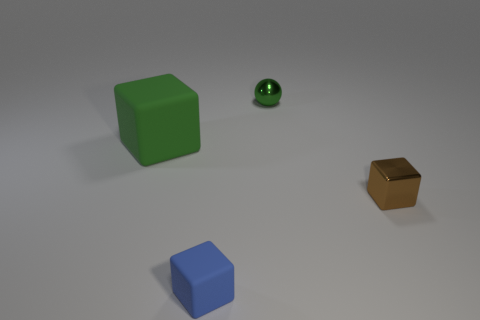Can you tell me what materials the objects might be made from? Based on their appearance in the image, the green cube looks like it could be made of a matte plastic material, the shiny green ball seems metallic, the golden cube possibly gold foil, and the blue cube has a similar matte finish to the green one, suggesting it might also be made of plastic. 